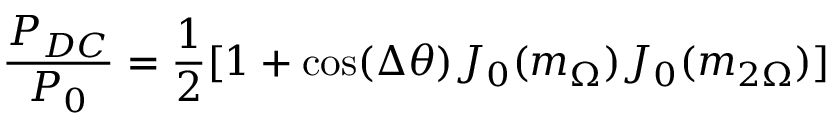Convert formula to latex. <formula><loc_0><loc_0><loc_500><loc_500>\frac { P _ { D C } } { P _ { 0 } } = \frac { 1 } { 2 } [ 1 + \cos ( \Delta \theta ) J _ { 0 } ( m _ { \Omega } ) J _ { 0 } ( m _ { 2 \Omega } ) ]</formula> 